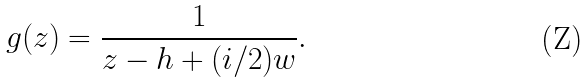<formula> <loc_0><loc_0><loc_500><loc_500>g ( z ) = \frac { 1 } { z - h + ( i / 2 ) w } .</formula> 